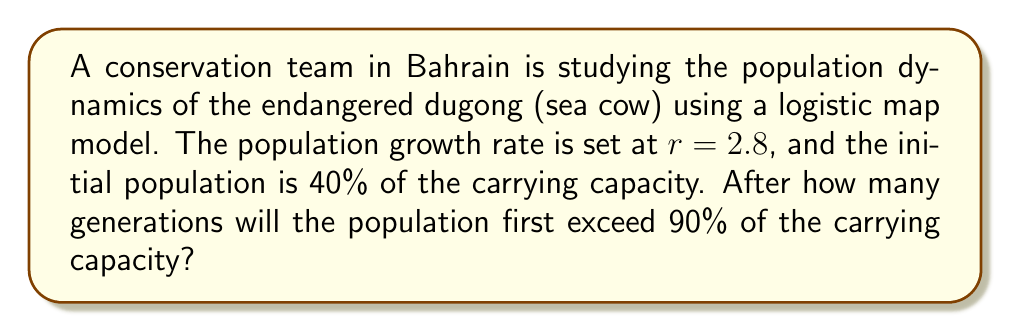Can you solve this math problem? Let's approach this step-by-step using the logistic map equation:

1) The logistic map is given by: $x_{n+1} = rx_n(1-x_n)$

2) We're given $r = 2.8$ and $x_0 = 0.4$ (40% of carrying capacity)

3) We need to iterate this map until $x_n > 0.9$ for the first time

4) Let's calculate the first few iterations:

   $x_1 = 2.8 * 0.4 * (1-0.4) = 0.672$
   $x_2 = 2.8 * 0.672 * (1-0.672) = 0.8888$
   $x_3 = 2.8 * 0.8888 * (1-0.8888) = 0.8754$
   $x_4 = 2.8 * 0.8754 * (1-0.8754) = 0.9066$

5) We see that after 4 generations, the population exceeds 90% of the carrying capacity for the first time.

This demonstrates how quickly populations can grow under the logistic map model, which is relevant for understanding and managing endangered species populations in ecosystems like Bahrain's coastal waters.
Answer: 4 generations 